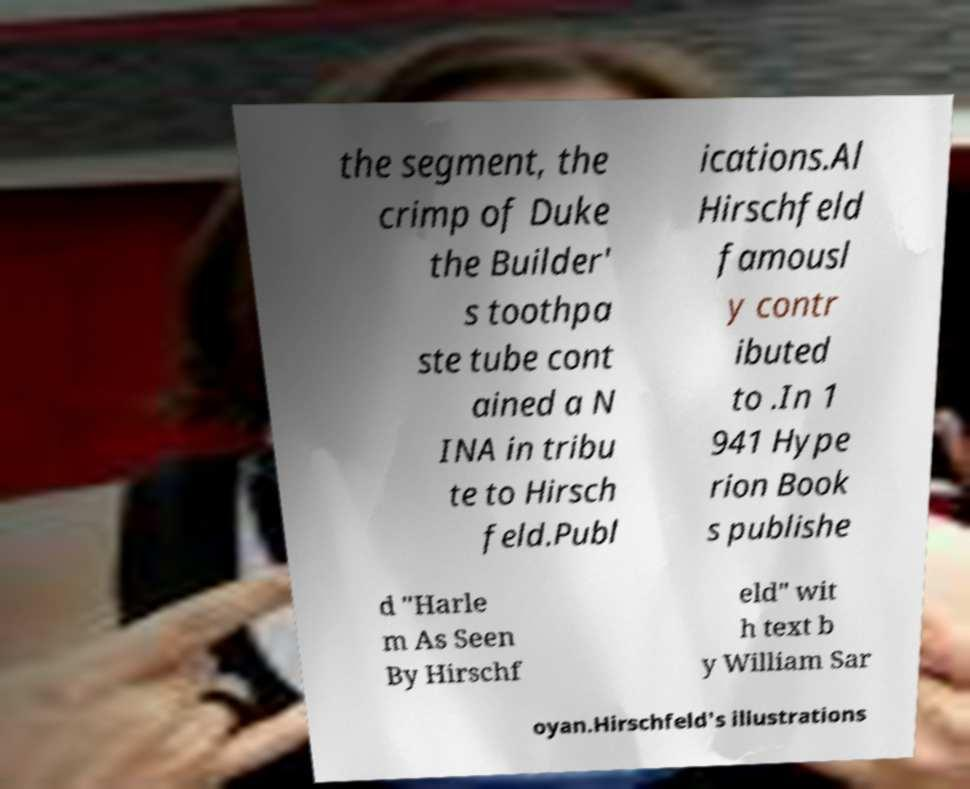For documentation purposes, I need the text within this image transcribed. Could you provide that? the segment, the crimp of Duke the Builder' s toothpa ste tube cont ained a N INA in tribu te to Hirsch feld.Publ ications.Al Hirschfeld famousl y contr ibuted to .In 1 941 Hype rion Book s publishe d "Harle m As Seen By Hirschf eld" wit h text b y William Sar oyan.Hirschfeld's illustrations 